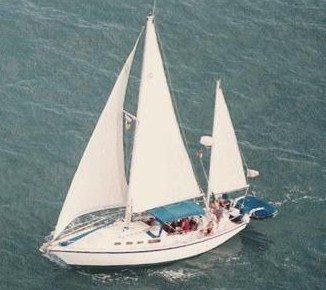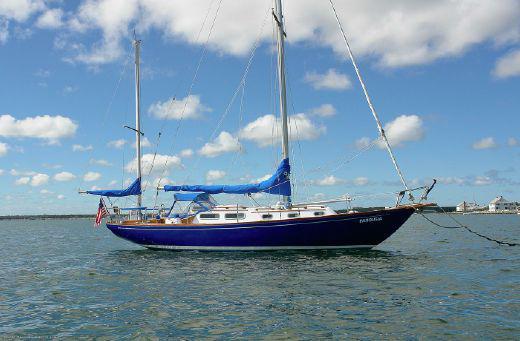The first image is the image on the left, the second image is the image on the right. Assess this claim about the two images: "At least one of the images has a sky with nimbus clouds.". Correct or not? Answer yes or no. Yes. The first image is the image on the left, the second image is the image on the right. Evaluate the accuracy of this statement regarding the images: "At least one boat has three sails up.". Is it true? Answer yes or no. Yes. 